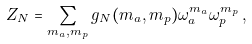<formula> <loc_0><loc_0><loc_500><loc_500>Z _ { N } = \sum _ { m _ { a } , m _ { p } } g _ { N } ( m _ { a } , m _ { p } ) \omega _ { a } ^ { m _ { a } } \omega _ { p } ^ { m _ { p } } \, ,</formula> 